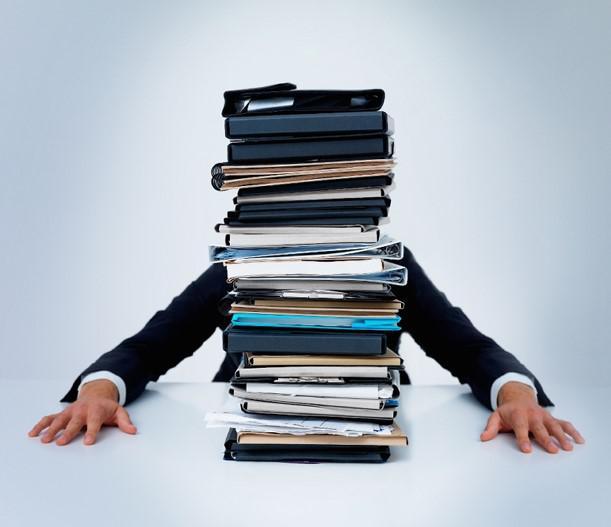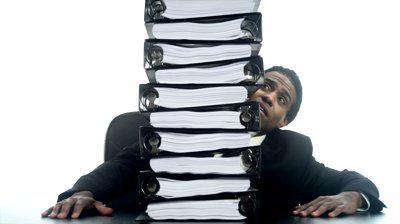The first image is the image on the left, the second image is the image on the right. Analyze the images presented: Is the assertion "A man's face is visible near a stack of books." valid? Answer yes or no. Yes. 